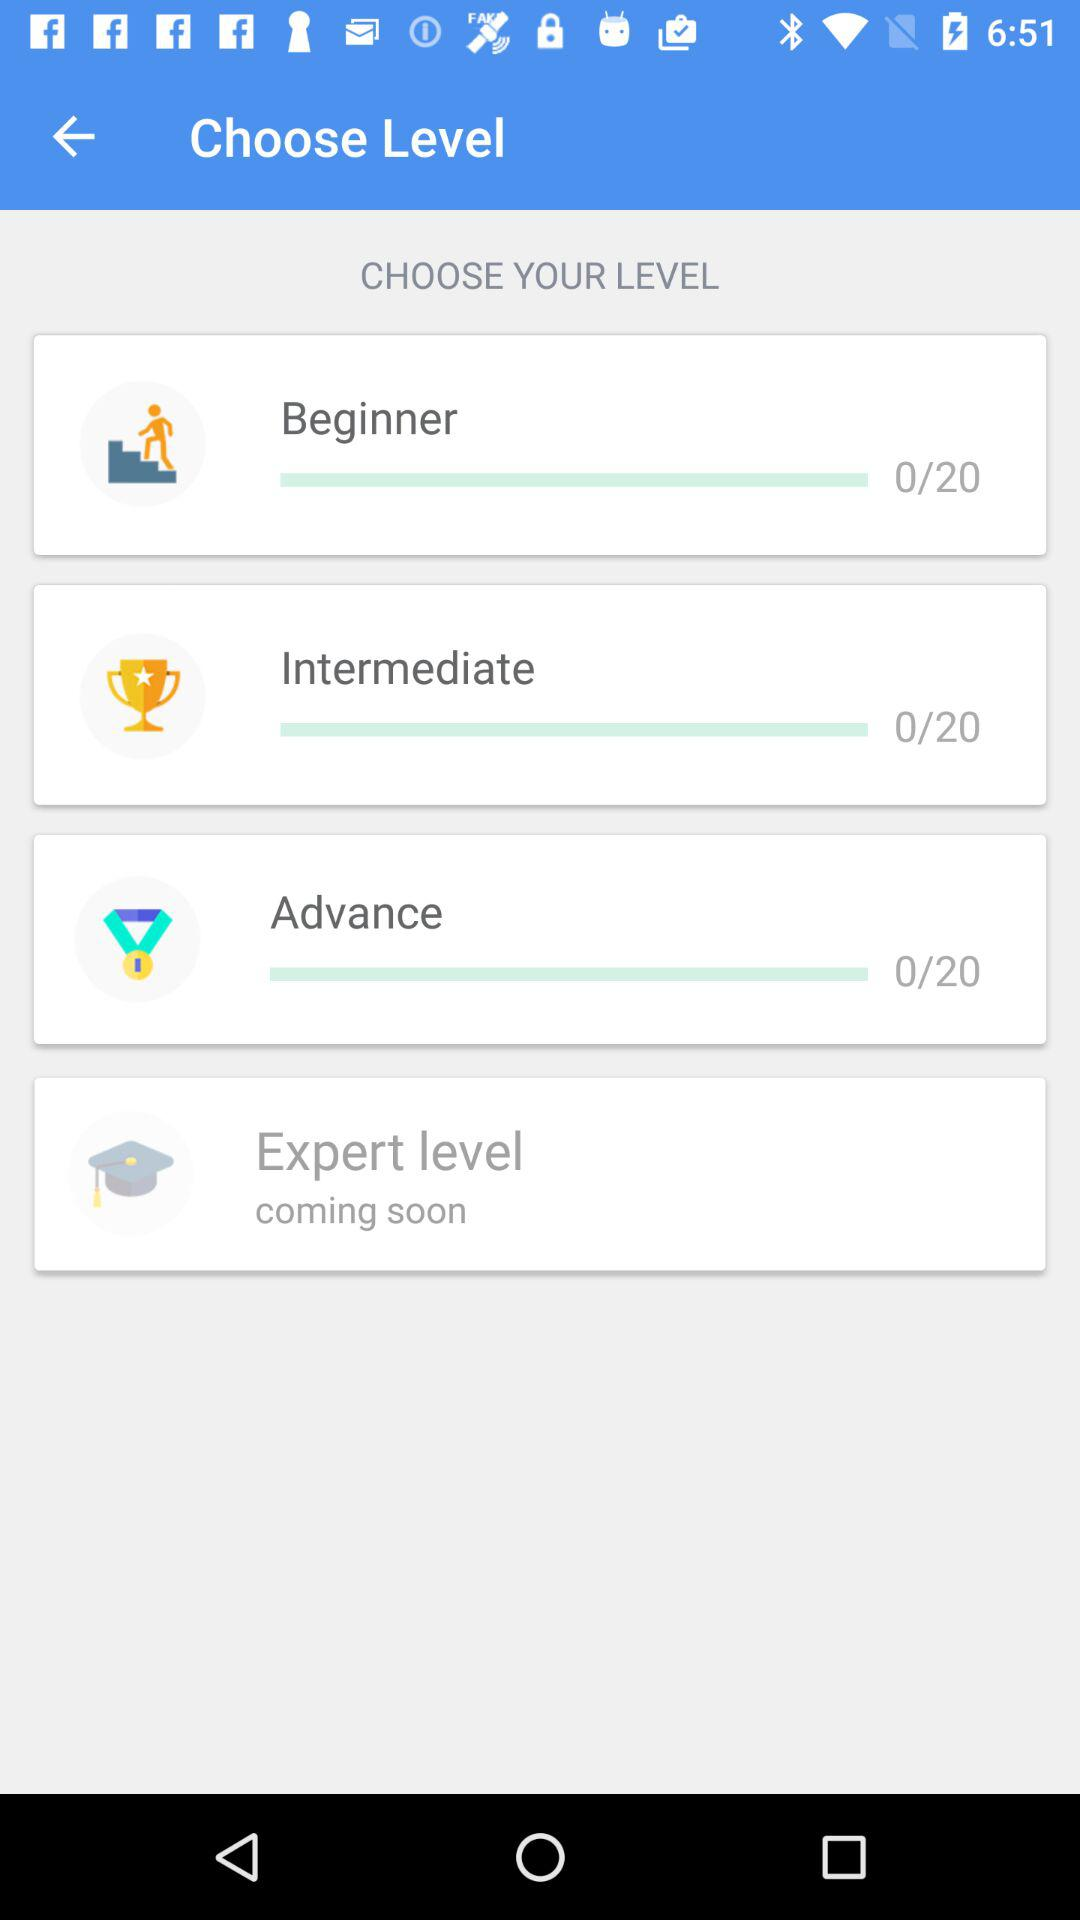What are the options available under "LEARN" in "Hinkhoj Dictionary"? The options available under "LEARN" in "Hinkhoj Dictionary" are "Vocabulary Builder", "Word Guess Game", "Cross Word Game" and "Scrabble Game". 